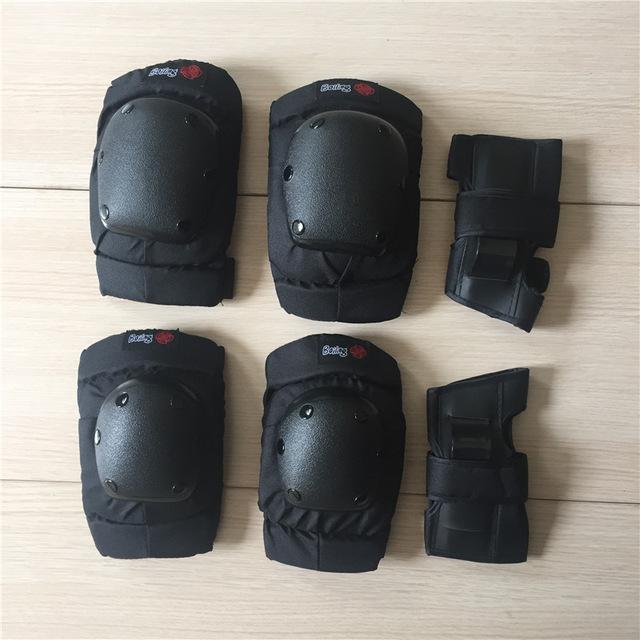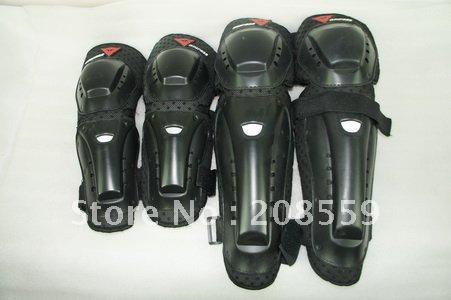The first image is the image on the left, the second image is the image on the right. For the images shown, is this caption "Some knee pads have a camouflage design." true? Answer yes or no. No. The first image is the image on the left, the second image is the image on the right. Assess this claim about the two images: "The right image contains exactly two pairs of black pads arranged with one pair above the other.". Correct or not? Answer yes or no. No. 